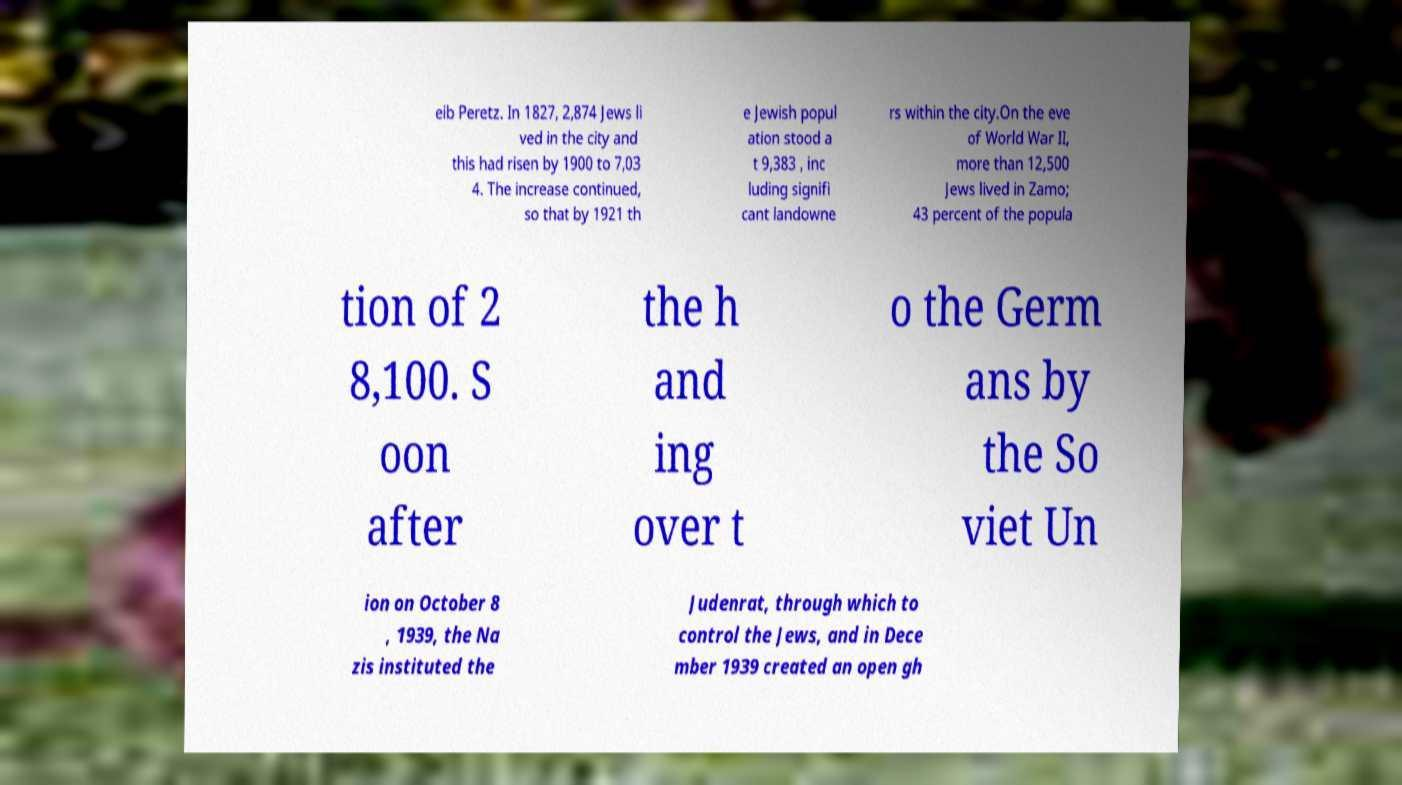For documentation purposes, I need the text within this image transcribed. Could you provide that? eib Peretz. In 1827, 2,874 Jews li ved in the city and this had risen by 1900 to 7,03 4. The increase continued, so that by 1921 th e Jewish popul ation stood a t 9,383 , inc luding signifi cant landowne rs within the city.On the eve of World War II, more than 12,500 Jews lived in Zamo; 43 percent of the popula tion of 2 8,100. S oon after the h and ing over t o the Germ ans by the So viet Un ion on October 8 , 1939, the Na zis instituted the Judenrat, through which to control the Jews, and in Dece mber 1939 created an open gh 